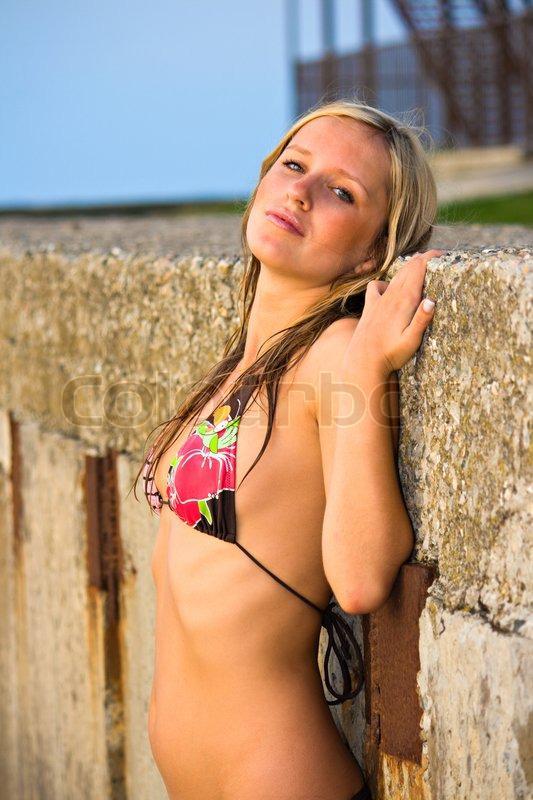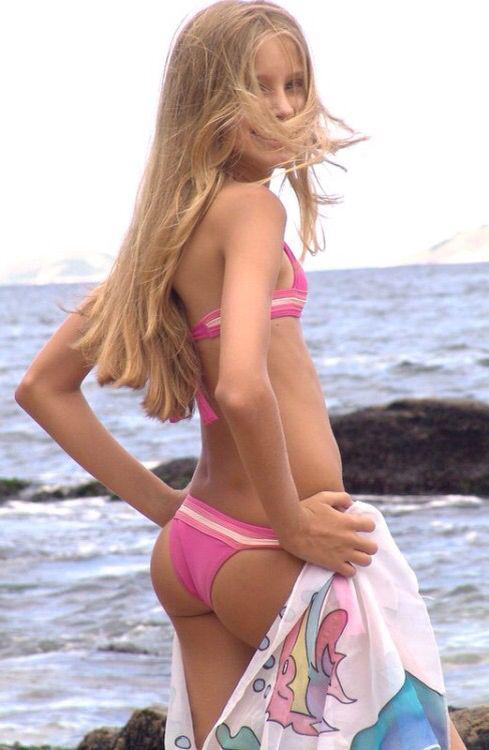The first image is the image on the left, the second image is the image on the right. For the images shown, is this caption "All of the models are shown from the front, and are wearing tops that can be seen to loop around the neck." true? Answer yes or no. No. The first image is the image on the left, the second image is the image on the right. Evaluate the accuracy of this statement regarding the images: "The woman on the left has on a light blue bikini.". Is it true? Answer yes or no. No. 